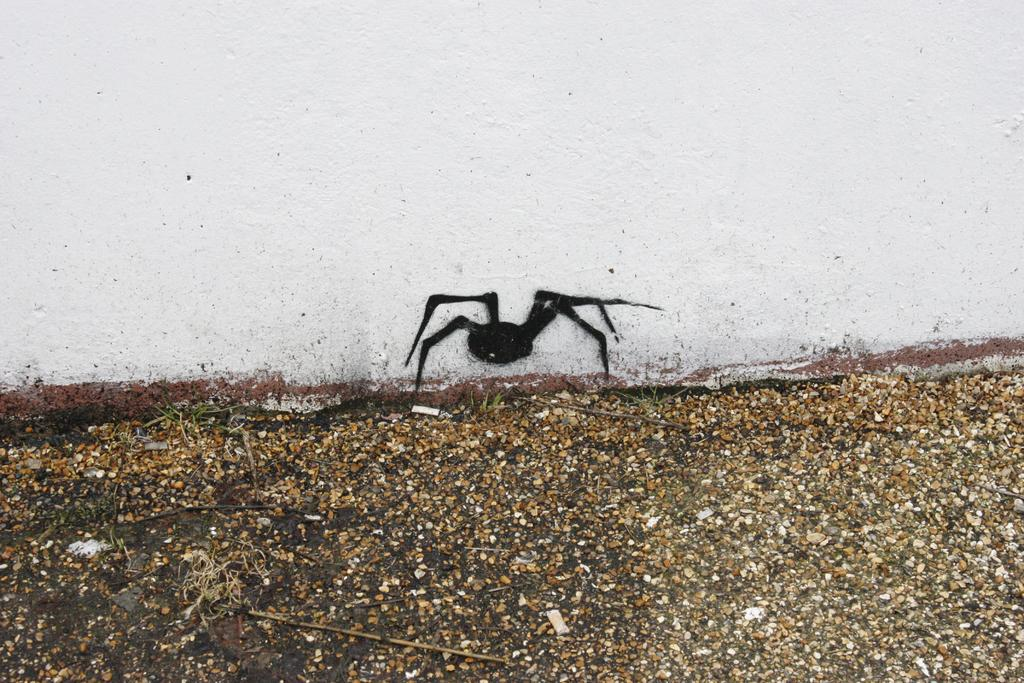What type of surface is visible in the image? There is a ground visible in the image. What color is the wall in the image? There is a white-colored wall in the image. What is depicted on the wall in the image? There is a black-colored painting of an insect on the wall. Can you tell me how the lake is being treated in the image? There is no lake present in the image, so it is not possible to discuss any treatment. Is there any steam visible in the image? There is no steam present in the image. 